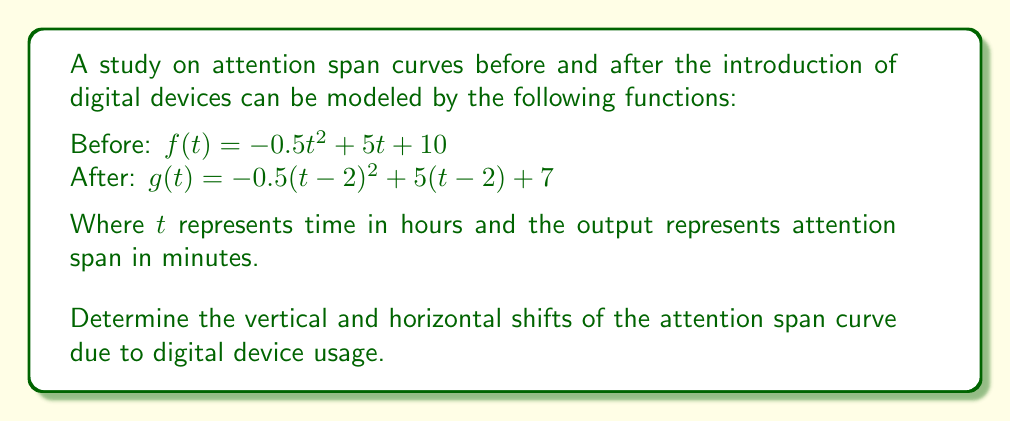Solve this math problem. To determine the vertical and horizontal shifts, we need to compare the general forms of the two functions:

1) Original function (before digital devices):
   $f(t) = -0.5t^2 + 5t + 10$

2) Transformed function (after digital devices):
   $g(t) = -0.5(t-2)^2 + 5(t-2) + 7$

3) Let's rewrite $g(t)$ in the form of $f(t-h) + k$, where $h$ represents the horizontal shift and $k$ represents the vertical shift:

   $g(t) = -0.5(t-2)^2 + 5(t-2) + 7$
         $= [-0.5(t-2)^2 + 5(t-2) + 10] - 3$
         $= f(t-2) - 3$

4) From this form, we can identify:
   - Horizontal shift: $h = 2$ (positive, meaning a shift to the right)
   - Vertical shift: $k = -3$ (negative, meaning a shift downward)

5) Interpretation:
   - The horizontal shift of 2 units to the right indicates that peak attention span is delayed by 2 hours after the introduction of digital devices.
   - The vertical shift of 3 units downward suggests that the overall attention span has decreased by 3 minutes at each corresponding point in time.
Answer: Horizontal shift: 2 units right; Vertical shift: 3 units down 